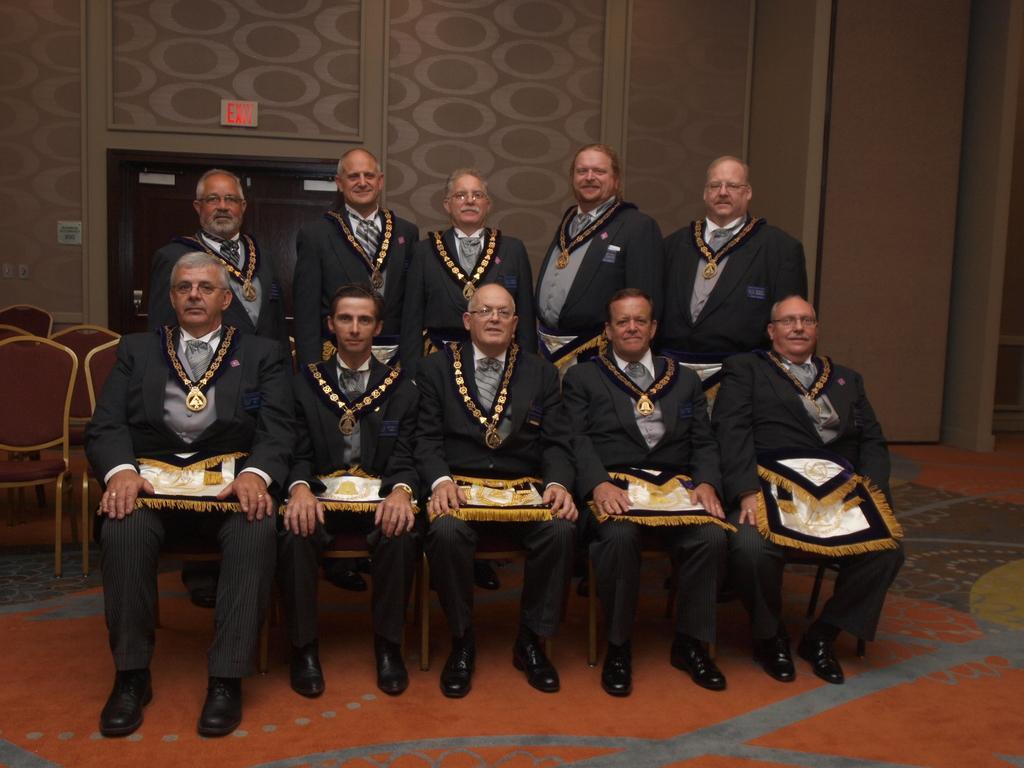Describe this image in one or two sentences. In this image I can see the group of people. These people are wearing the black color blazers and holding some clothes. To the left I can see some maroon color chairs. In the back I can see the exit board to the wall. 